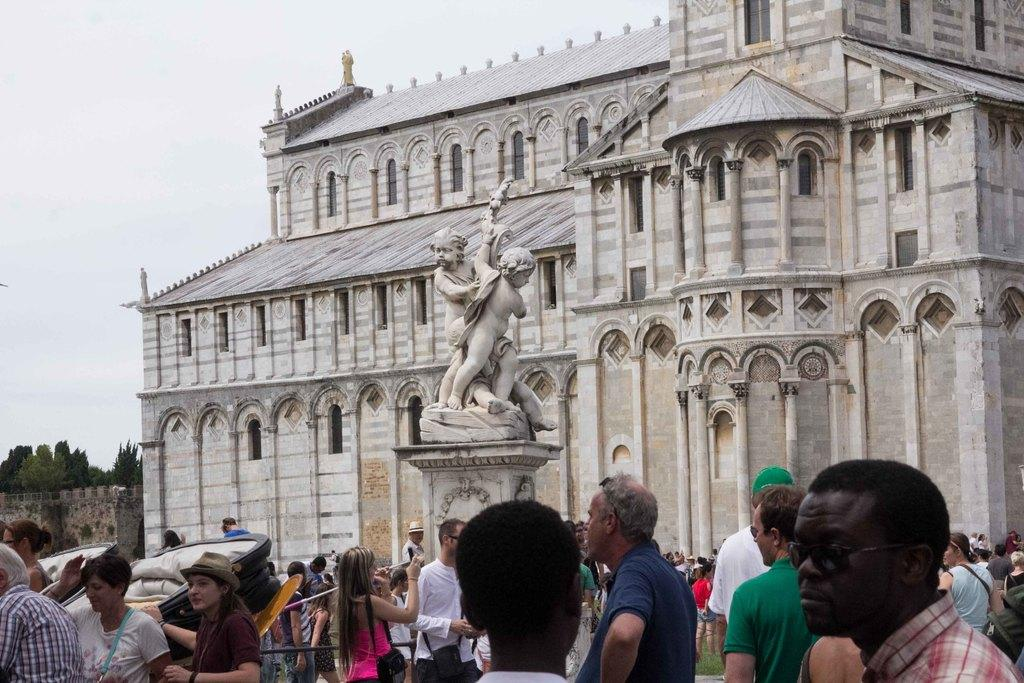What are the people in the image doing? The people in the image are standing on the ground. What can be seen in the background of the image? There is a statue and a building visible in the background of the image. What type of vegetation is on the left side of the image? Trees are present on the left side of the image. What is visible in the image besides the people and the background? The sky is visible in the image. What type of owl can be seen sitting on the statue in the image? There is no owl present on the statue in the image. What type of bun is being served to the people in the image? There is no mention of any bun being served in the image. 